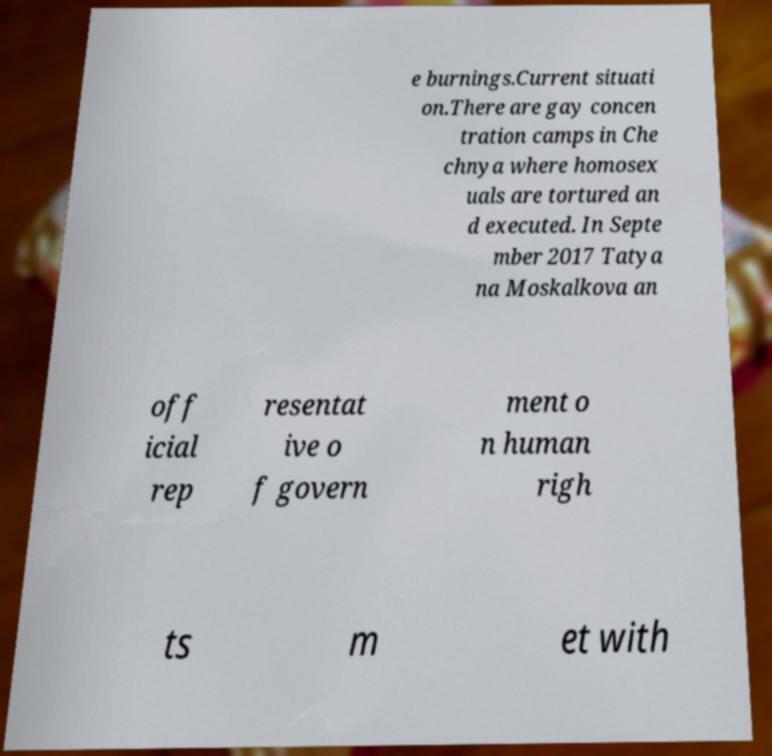Could you assist in decoding the text presented in this image and type it out clearly? e burnings.Current situati on.There are gay concen tration camps in Che chnya where homosex uals are tortured an d executed. In Septe mber 2017 Tatya na Moskalkova an off icial rep resentat ive o f govern ment o n human righ ts m et with 